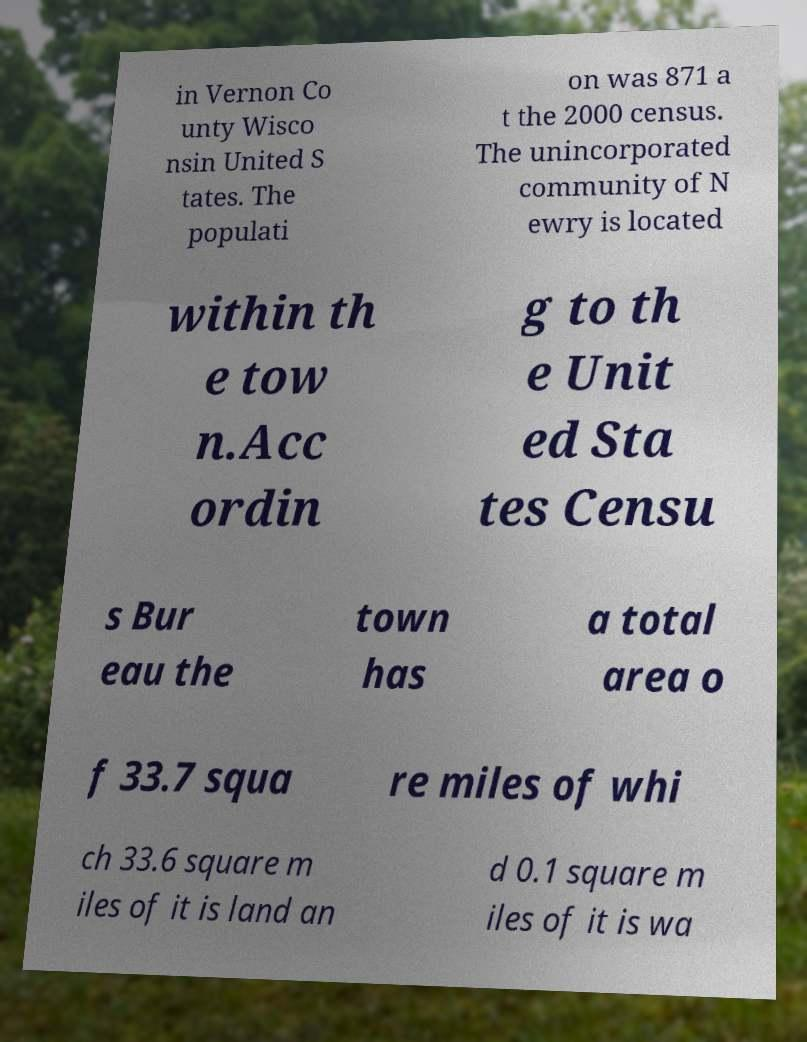Please identify and transcribe the text found in this image. in Vernon Co unty Wisco nsin United S tates. The populati on was 871 a t the 2000 census. The unincorporated community of N ewry is located within th e tow n.Acc ordin g to th e Unit ed Sta tes Censu s Bur eau the town has a total area o f 33.7 squa re miles of whi ch 33.6 square m iles of it is land an d 0.1 square m iles of it is wa 